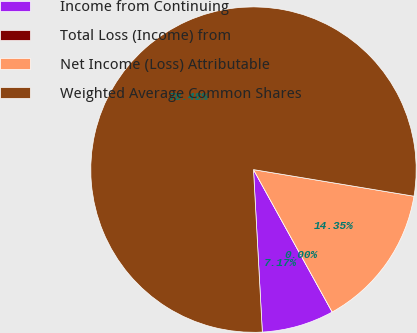<chart> <loc_0><loc_0><loc_500><loc_500><pie_chart><fcel>Income from Continuing<fcel>Total Loss (Income) from<fcel>Net Income (Loss) Attributable<fcel>Weighted Average Common Shares<nl><fcel>7.17%<fcel>0.0%<fcel>14.35%<fcel>78.48%<nl></chart> 